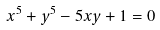Convert formula to latex. <formula><loc_0><loc_0><loc_500><loc_500>x ^ { 5 } + y ^ { 5 } - 5 x y + 1 = 0</formula> 